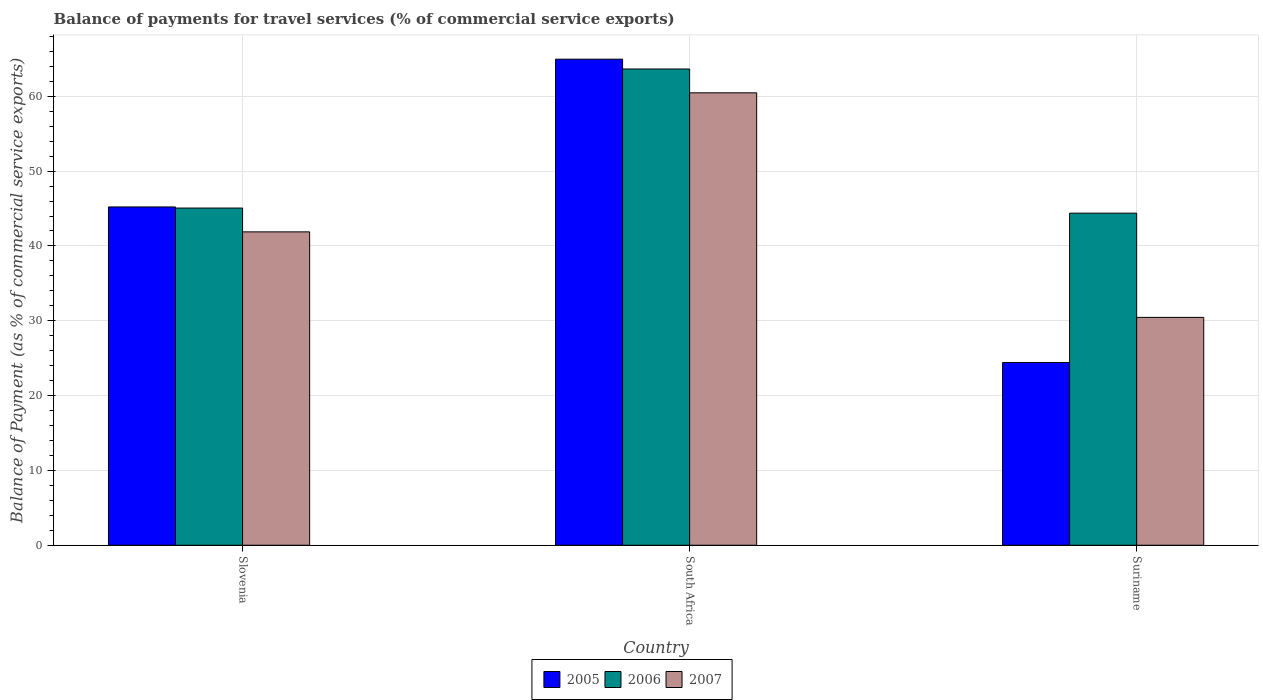How many different coloured bars are there?
Give a very brief answer. 3. How many groups of bars are there?
Give a very brief answer. 3. Are the number of bars on each tick of the X-axis equal?
Keep it short and to the point. Yes. How many bars are there on the 1st tick from the left?
Offer a terse response. 3. What is the label of the 1st group of bars from the left?
Keep it short and to the point. Slovenia. In how many cases, is the number of bars for a given country not equal to the number of legend labels?
Make the answer very short. 0. What is the balance of payments for travel services in 2005 in Slovenia?
Provide a short and direct response. 45.21. Across all countries, what is the maximum balance of payments for travel services in 2006?
Make the answer very short. 63.65. Across all countries, what is the minimum balance of payments for travel services in 2006?
Your response must be concise. 44.38. In which country was the balance of payments for travel services in 2007 maximum?
Provide a succinct answer. South Africa. In which country was the balance of payments for travel services in 2005 minimum?
Keep it short and to the point. Suriname. What is the total balance of payments for travel services in 2005 in the graph?
Your answer should be very brief. 134.6. What is the difference between the balance of payments for travel services in 2006 in Slovenia and that in South Africa?
Your response must be concise. -18.59. What is the difference between the balance of payments for travel services in 2006 in Suriname and the balance of payments for travel services in 2005 in South Africa?
Provide a succinct answer. -20.58. What is the average balance of payments for travel services in 2007 per country?
Ensure brevity in your answer.  44.27. What is the difference between the balance of payments for travel services of/in 2006 and balance of payments for travel services of/in 2007 in South Africa?
Your response must be concise. 3.18. What is the ratio of the balance of payments for travel services in 2005 in South Africa to that in Suriname?
Offer a terse response. 2.66. Is the balance of payments for travel services in 2007 in Slovenia less than that in Suriname?
Your answer should be compact. No. Is the difference between the balance of payments for travel services in 2006 in Slovenia and South Africa greater than the difference between the balance of payments for travel services in 2007 in Slovenia and South Africa?
Offer a terse response. No. What is the difference between the highest and the second highest balance of payments for travel services in 2007?
Your response must be concise. -18.58. What is the difference between the highest and the lowest balance of payments for travel services in 2005?
Make the answer very short. 40.54. Is the sum of the balance of payments for travel services in 2006 in Slovenia and Suriname greater than the maximum balance of payments for travel services in 2005 across all countries?
Keep it short and to the point. Yes. What does the 3rd bar from the left in Suriname represents?
Provide a short and direct response. 2007. What does the 1st bar from the right in South Africa represents?
Offer a terse response. 2007. How many bars are there?
Give a very brief answer. 9. Are the values on the major ticks of Y-axis written in scientific E-notation?
Give a very brief answer. No. Does the graph contain grids?
Ensure brevity in your answer.  Yes. What is the title of the graph?
Your response must be concise. Balance of payments for travel services (% of commercial service exports). Does "2015" appear as one of the legend labels in the graph?
Your response must be concise. No. What is the label or title of the X-axis?
Give a very brief answer. Country. What is the label or title of the Y-axis?
Offer a very short reply. Balance of Payment (as % of commercial service exports). What is the Balance of Payment (as % of commercial service exports) of 2005 in Slovenia?
Offer a terse response. 45.21. What is the Balance of Payment (as % of commercial service exports) in 2006 in Slovenia?
Keep it short and to the point. 45.06. What is the Balance of Payment (as % of commercial service exports) in 2007 in Slovenia?
Provide a short and direct response. 41.88. What is the Balance of Payment (as % of commercial service exports) in 2005 in South Africa?
Your answer should be compact. 64.96. What is the Balance of Payment (as % of commercial service exports) of 2006 in South Africa?
Make the answer very short. 63.65. What is the Balance of Payment (as % of commercial service exports) of 2007 in South Africa?
Make the answer very short. 60.46. What is the Balance of Payment (as % of commercial service exports) in 2005 in Suriname?
Provide a succinct answer. 24.42. What is the Balance of Payment (as % of commercial service exports) in 2006 in Suriname?
Make the answer very short. 44.38. What is the Balance of Payment (as % of commercial service exports) of 2007 in Suriname?
Make the answer very short. 30.45. Across all countries, what is the maximum Balance of Payment (as % of commercial service exports) of 2005?
Provide a short and direct response. 64.96. Across all countries, what is the maximum Balance of Payment (as % of commercial service exports) of 2006?
Provide a short and direct response. 63.65. Across all countries, what is the maximum Balance of Payment (as % of commercial service exports) in 2007?
Your answer should be very brief. 60.46. Across all countries, what is the minimum Balance of Payment (as % of commercial service exports) of 2005?
Your response must be concise. 24.42. Across all countries, what is the minimum Balance of Payment (as % of commercial service exports) of 2006?
Offer a terse response. 44.38. Across all countries, what is the minimum Balance of Payment (as % of commercial service exports) in 2007?
Offer a terse response. 30.45. What is the total Balance of Payment (as % of commercial service exports) of 2005 in the graph?
Your response must be concise. 134.6. What is the total Balance of Payment (as % of commercial service exports) of 2006 in the graph?
Provide a short and direct response. 153.09. What is the total Balance of Payment (as % of commercial service exports) of 2007 in the graph?
Keep it short and to the point. 132.8. What is the difference between the Balance of Payment (as % of commercial service exports) in 2005 in Slovenia and that in South Africa?
Provide a short and direct response. -19.75. What is the difference between the Balance of Payment (as % of commercial service exports) in 2006 in Slovenia and that in South Africa?
Offer a terse response. -18.59. What is the difference between the Balance of Payment (as % of commercial service exports) of 2007 in Slovenia and that in South Africa?
Your response must be concise. -18.58. What is the difference between the Balance of Payment (as % of commercial service exports) of 2005 in Slovenia and that in Suriname?
Your response must be concise. 20.79. What is the difference between the Balance of Payment (as % of commercial service exports) of 2006 in Slovenia and that in Suriname?
Ensure brevity in your answer.  0.68. What is the difference between the Balance of Payment (as % of commercial service exports) in 2007 in Slovenia and that in Suriname?
Give a very brief answer. 11.43. What is the difference between the Balance of Payment (as % of commercial service exports) of 2005 in South Africa and that in Suriname?
Provide a succinct answer. 40.54. What is the difference between the Balance of Payment (as % of commercial service exports) in 2006 in South Africa and that in Suriname?
Your answer should be compact. 19.27. What is the difference between the Balance of Payment (as % of commercial service exports) in 2007 in South Africa and that in Suriname?
Offer a terse response. 30.01. What is the difference between the Balance of Payment (as % of commercial service exports) in 2005 in Slovenia and the Balance of Payment (as % of commercial service exports) in 2006 in South Africa?
Your answer should be compact. -18.44. What is the difference between the Balance of Payment (as % of commercial service exports) in 2005 in Slovenia and the Balance of Payment (as % of commercial service exports) in 2007 in South Africa?
Ensure brevity in your answer.  -15.25. What is the difference between the Balance of Payment (as % of commercial service exports) in 2006 in Slovenia and the Balance of Payment (as % of commercial service exports) in 2007 in South Africa?
Offer a terse response. -15.4. What is the difference between the Balance of Payment (as % of commercial service exports) in 2005 in Slovenia and the Balance of Payment (as % of commercial service exports) in 2006 in Suriname?
Provide a succinct answer. 0.83. What is the difference between the Balance of Payment (as % of commercial service exports) in 2005 in Slovenia and the Balance of Payment (as % of commercial service exports) in 2007 in Suriname?
Keep it short and to the point. 14.76. What is the difference between the Balance of Payment (as % of commercial service exports) in 2006 in Slovenia and the Balance of Payment (as % of commercial service exports) in 2007 in Suriname?
Make the answer very short. 14.61. What is the difference between the Balance of Payment (as % of commercial service exports) of 2005 in South Africa and the Balance of Payment (as % of commercial service exports) of 2006 in Suriname?
Offer a very short reply. 20.58. What is the difference between the Balance of Payment (as % of commercial service exports) of 2005 in South Africa and the Balance of Payment (as % of commercial service exports) of 2007 in Suriname?
Provide a succinct answer. 34.51. What is the difference between the Balance of Payment (as % of commercial service exports) in 2006 in South Africa and the Balance of Payment (as % of commercial service exports) in 2007 in Suriname?
Provide a short and direct response. 33.2. What is the average Balance of Payment (as % of commercial service exports) in 2005 per country?
Your answer should be very brief. 44.87. What is the average Balance of Payment (as % of commercial service exports) in 2006 per country?
Offer a very short reply. 51.03. What is the average Balance of Payment (as % of commercial service exports) of 2007 per country?
Make the answer very short. 44.27. What is the difference between the Balance of Payment (as % of commercial service exports) in 2005 and Balance of Payment (as % of commercial service exports) in 2006 in Slovenia?
Provide a succinct answer. 0.15. What is the difference between the Balance of Payment (as % of commercial service exports) in 2005 and Balance of Payment (as % of commercial service exports) in 2007 in Slovenia?
Provide a short and direct response. 3.33. What is the difference between the Balance of Payment (as % of commercial service exports) in 2006 and Balance of Payment (as % of commercial service exports) in 2007 in Slovenia?
Your answer should be compact. 3.18. What is the difference between the Balance of Payment (as % of commercial service exports) of 2005 and Balance of Payment (as % of commercial service exports) of 2006 in South Africa?
Give a very brief answer. 1.31. What is the difference between the Balance of Payment (as % of commercial service exports) of 2005 and Balance of Payment (as % of commercial service exports) of 2007 in South Africa?
Give a very brief answer. 4.5. What is the difference between the Balance of Payment (as % of commercial service exports) in 2006 and Balance of Payment (as % of commercial service exports) in 2007 in South Africa?
Your answer should be compact. 3.18. What is the difference between the Balance of Payment (as % of commercial service exports) of 2005 and Balance of Payment (as % of commercial service exports) of 2006 in Suriname?
Ensure brevity in your answer.  -19.96. What is the difference between the Balance of Payment (as % of commercial service exports) of 2005 and Balance of Payment (as % of commercial service exports) of 2007 in Suriname?
Your answer should be very brief. -6.03. What is the difference between the Balance of Payment (as % of commercial service exports) in 2006 and Balance of Payment (as % of commercial service exports) in 2007 in Suriname?
Keep it short and to the point. 13.93. What is the ratio of the Balance of Payment (as % of commercial service exports) of 2005 in Slovenia to that in South Africa?
Provide a succinct answer. 0.7. What is the ratio of the Balance of Payment (as % of commercial service exports) in 2006 in Slovenia to that in South Africa?
Keep it short and to the point. 0.71. What is the ratio of the Balance of Payment (as % of commercial service exports) of 2007 in Slovenia to that in South Africa?
Your answer should be compact. 0.69. What is the ratio of the Balance of Payment (as % of commercial service exports) of 2005 in Slovenia to that in Suriname?
Provide a short and direct response. 1.85. What is the ratio of the Balance of Payment (as % of commercial service exports) in 2006 in Slovenia to that in Suriname?
Your answer should be compact. 1.02. What is the ratio of the Balance of Payment (as % of commercial service exports) of 2007 in Slovenia to that in Suriname?
Offer a terse response. 1.38. What is the ratio of the Balance of Payment (as % of commercial service exports) of 2005 in South Africa to that in Suriname?
Ensure brevity in your answer.  2.66. What is the ratio of the Balance of Payment (as % of commercial service exports) in 2006 in South Africa to that in Suriname?
Offer a very short reply. 1.43. What is the ratio of the Balance of Payment (as % of commercial service exports) of 2007 in South Africa to that in Suriname?
Keep it short and to the point. 1.99. What is the difference between the highest and the second highest Balance of Payment (as % of commercial service exports) in 2005?
Offer a terse response. 19.75. What is the difference between the highest and the second highest Balance of Payment (as % of commercial service exports) in 2006?
Give a very brief answer. 18.59. What is the difference between the highest and the second highest Balance of Payment (as % of commercial service exports) of 2007?
Keep it short and to the point. 18.58. What is the difference between the highest and the lowest Balance of Payment (as % of commercial service exports) in 2005?
Keep it short and to the point. 40.54. What is the difference between the highest and the lowest Balance of Payment (as % of commercial service exports) of 2006?
Your answer should be very brief. 19.27. What is the difference between the highest and the lowest Balance of Payment (as % of commercial service exports) of 2007?
Provide a succinct answer. 30.01. 